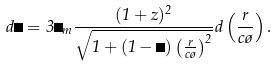<formula> <loc_0><loc_0><loc_500><loc_500>d \Omega = 3 \Omega _ { m } \frac { ( 1 + z ) ^ { 2 } } { \sqrt { 1 + ( 1 - \Omega ) \left ( \frac { r } { c \tau } \right ) ^ { 2 } } } d \left ( \frac { r } { c \tau } \right ) .</formula> 